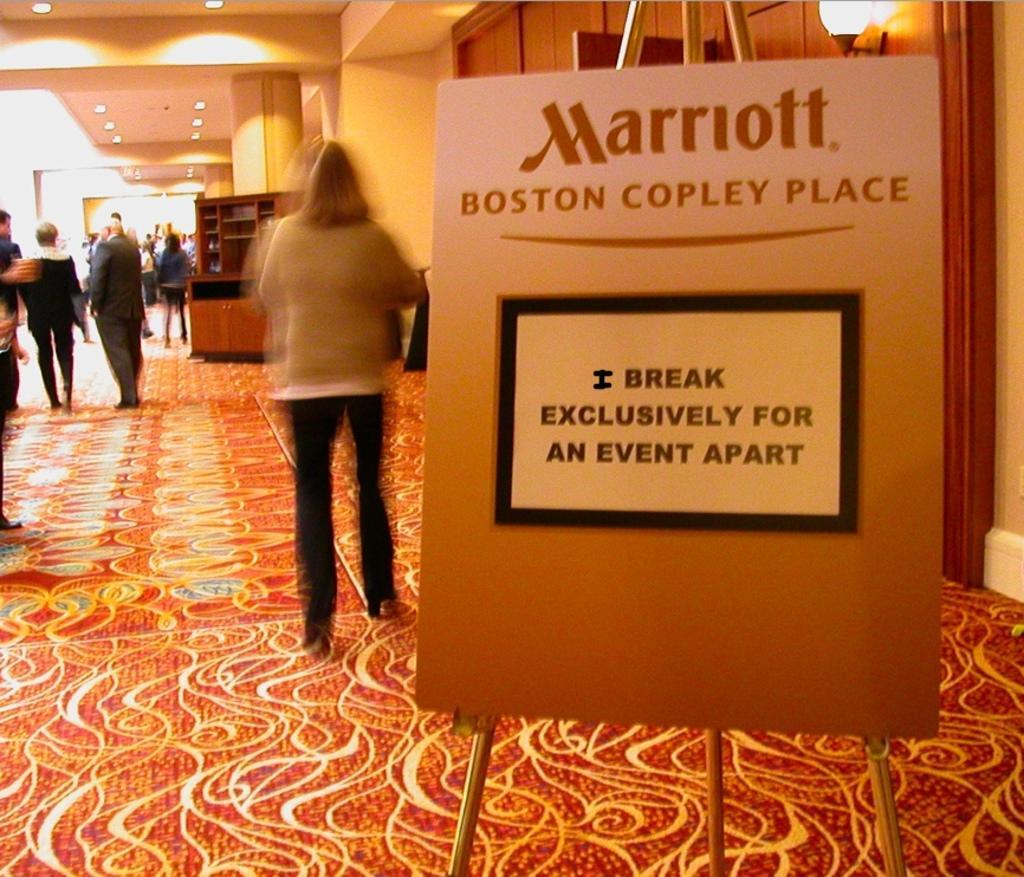Please provide a concise description of this image. In this picture we can observe a board to this stand. There are some people standing and walking. We can observe a cupboard here. There is a pillar. We can observe some lights to the ceilings. In the background there is a wall. 